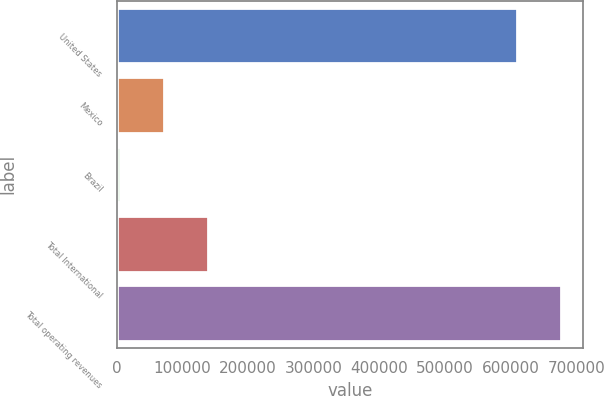Convert chart. <chart><loc_0><loc_0><loc_500><loc_500><bar_chart><fcel>United States<fcel>Mexico<fcel>Brazil<fcel>Total International<fcel>Total operating revenues<nl><fcel>610085<fcel>72009.1<fcel>5001<fcel>139017<fcel>677093<nl></chart> 